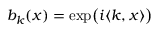<formula> <loc_0><loc_0><loc_500><loc_500>b _ { k } ( x ) = \exp \left ( i \langle k , x \rangle \right )</formula> 